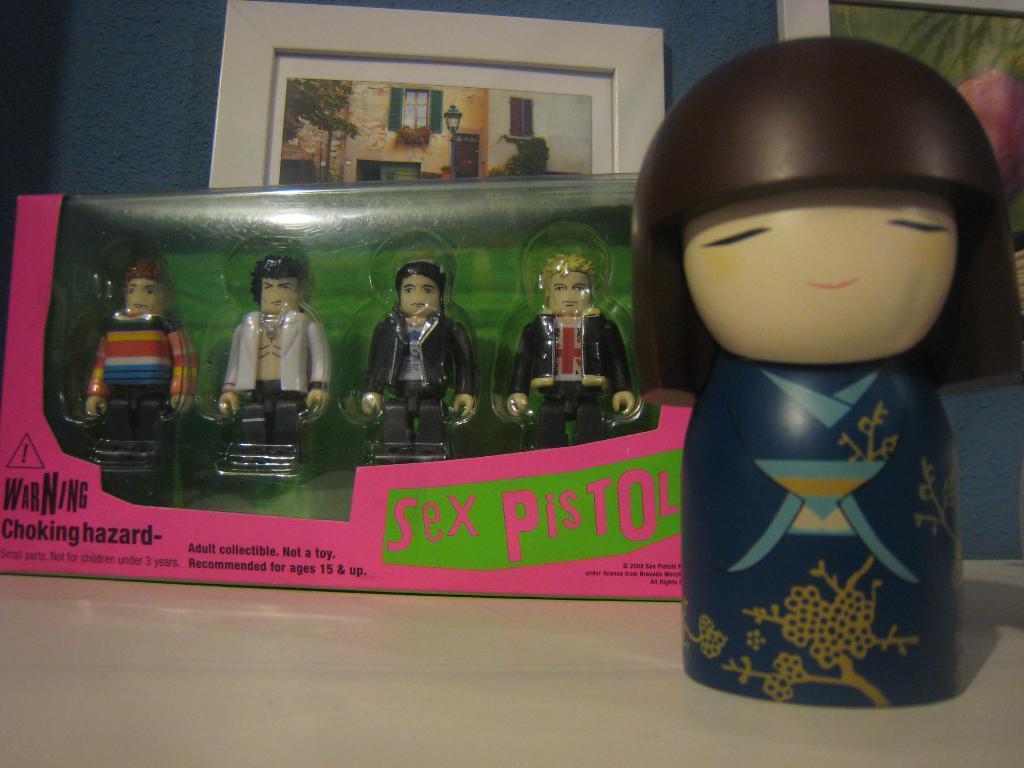Could you give a brief overview of what you see in this image? This is a zoomed picture. In the foreground there is a table on the top of which many number of toys are placed and we can see the text printed on the box. In the background there is a wall and we can see the picture frames seems to be hanging on the wall and and we can see the picture of building and some other objects in the picture frame. 